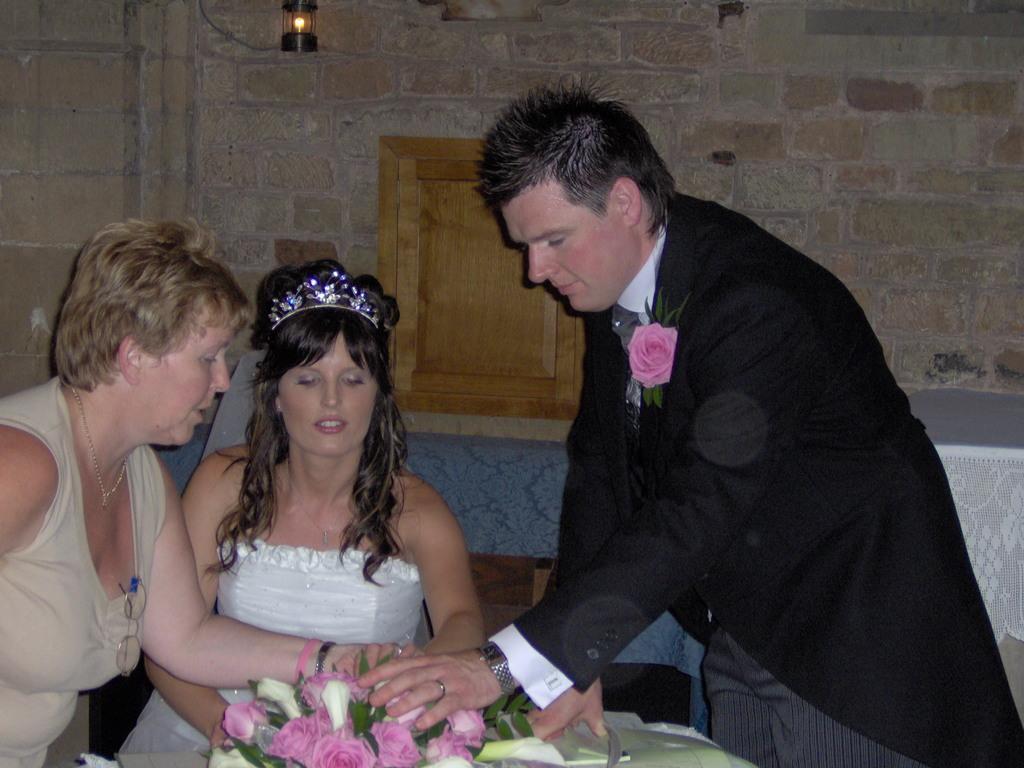Could you give a brief overview of what you see in this image? In this image, there are a few people. We can see some flowers and the wall with some objects. We can also see some objects on the right. We can also see a blue colored object. 